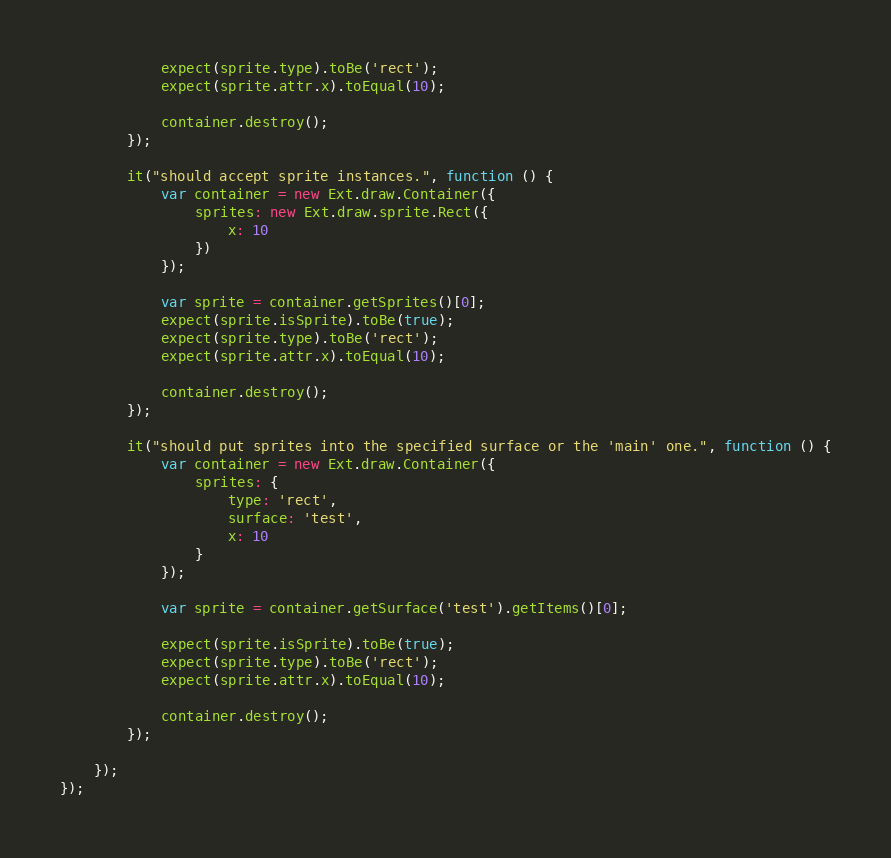Convert code to text. <code><loc_0><loc_0><loc_500><loc_500><_JavaScript_>            expect(sprite.type).toBe('rect');
            expect(sprite.attr.x).toEqual(10);

            container.destroy();
        });

        it("should accept sprite instances.", function () {
            var container = new Ext.draw.Container({
                sprites: new Ext.draw.sprite.Rect({
                    x: 10
                })
            });

            var sprite = container.getSprites()[0];
            expect(sprite.isSprite).toBe(true);
            expect(sprite.type).toBe('rect');
            expect(sprite.attr.x).toEqual(10);

            container.destroy();
        });

        it("should put sprites into the specified surface or the 'main' one.", function () {
            var container = new Ext.draw.Container({
                sprites: {
                    type: 'rect',
                    surface: 'test',
                    x: 10
                }
            });

            var sprite = container.getSurface('test').getItems()[0];

            expect(sprite.isSprite).toBe(true);
            expect(sprite.type).toBe('rect');
            expect(sprite.attr.x).toEqual(10);

            container.destroy();
        });

    });
});</code> 